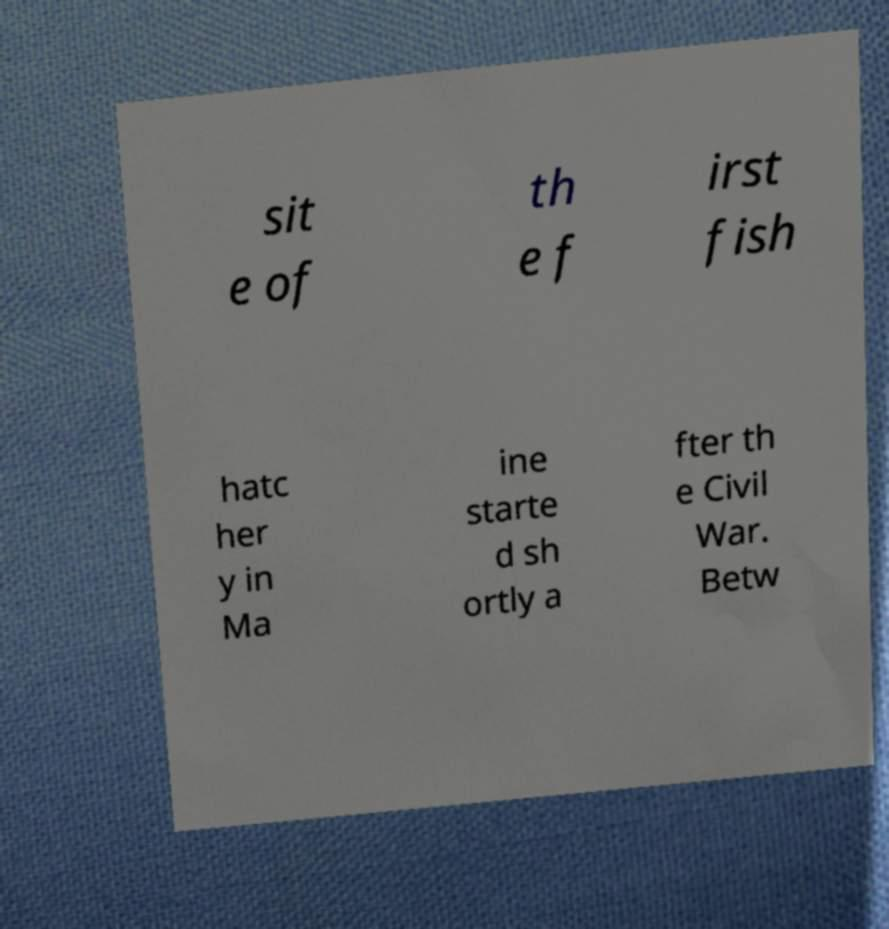Please identify and transcribe the text found in this image. sit e of th e f irst fish hatc her y in Ma ine starte d sh ortly a fter th e Civil War. Betw 